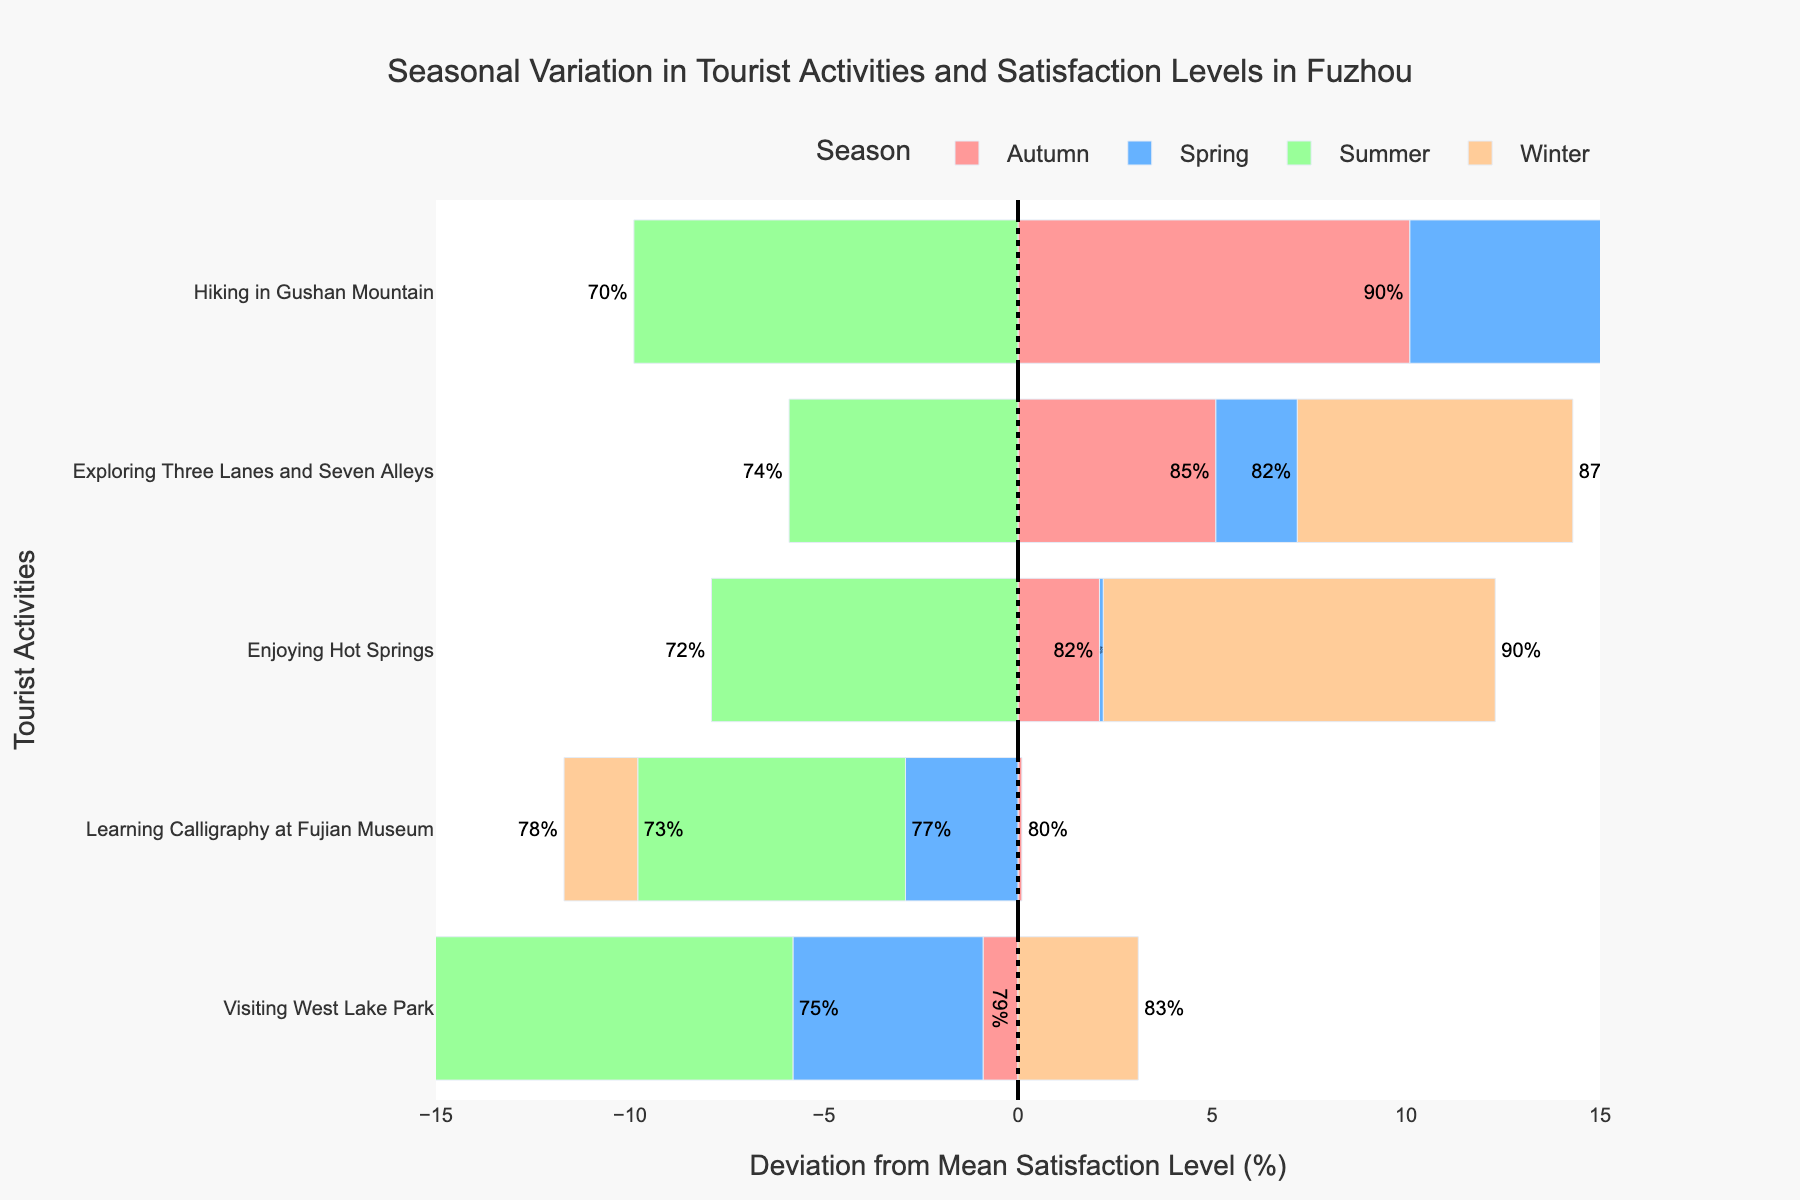What's the average satisfaction level of tourists hiking in Gushan Mountain across all seasons? Add the satisfaction levels for hiking in Gushan Mountain in all seasons (88 + 70 + 90 + 85) and then divide by the number of seasons (4). The sum is 333 and the average is 333 / 4 = 83.25
Answer: 83.25 Which tourist activity shows the highest satisfaction level in summer? Compare the satisfaction levels of all activities during the summer: Visiting West Lake Park (68), Exploring Three Lanes and Seven Alleys (74), Hiking in Gushan Mountain (70), Enjoying Hot Springs (72), Learning Calligraphy at Fujian Museum (73). The highest satisfaction level is for Exploring Three Lanes and Seven Alleys at 74%.
Answer: Exploring Three Lanes and Seven Alleys In which season do tourists have the lowest satisfaction level for visiting West Lake Park? Compare the satisfaction levels for Visiting West Lake Park in all seasons: Spring (75), Summer (68), Autumn (79), Winter (83). The lowest satisfaction level is in the Summer at 68%.
Answer: Summer What’s the difference in satisfaction levels for enjoying hot springs between Winter and Summer? Subtract the satisfaction level in Summer (72) from the satisfaction level in Winter (90). The difference is 90 - 72 = 18.
Answer: 18 Which season has the most activities with above-average satisfaction levels? Calculate the mean satisfaction level for all activities by summing satisfaction levels (75 + 82 + 88 + 80 + 77 + 68 + 74 + 70 + 72 + 73 + 79 + 85 + 90 + 82 + 80 + 83 + 87 + 85 + 90 + 78 = 1588) and dividing by the number of data points (20). The mean is 1588 / 20 = 79.4. Compare how many activities in each season exceed 79.4: Spring (2), Summer (0), Autumn (4), Winter (4). Both Autumn and Winter have the highest count, so the concise answer should be both.
Answer: Autumn and Winter Is satisfaction higher for hiking in Gushan Mountain in Autumn or Winter? Compare the satisfaction levels for hiking in Gushan Mountain between Autumn (90) and Winter (85). The satisfaction level is higher in Autumn.
Answer: Autumn How does the satisfaction level for exploring Three Lanes and Seven Alleys in Spring compare to Winter? Compare the satisfaction levels for Exploring Three Lanes and Seven Alleys in Spring (82) and Winter (87). The satisfaction level is lower in Spring.
Answer: Lower 